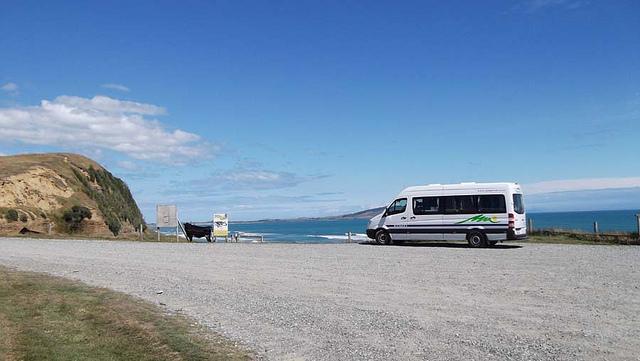Could a basketball team fit in this vehicle?
Answer briefly. Yes. Is this a tour bus?
Answer briefly. Yes. Is there an animal in front of the vehicle?
Quick response, please. Yes. What type of vehicle is this?
Keep it brief. Van. 